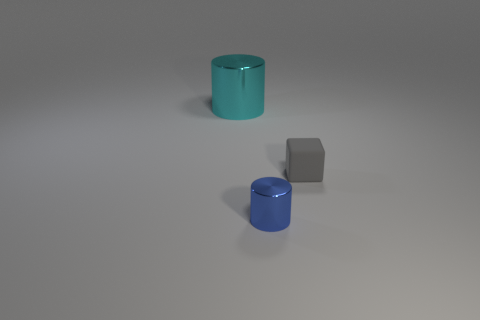Is there any other thing that is the same size as the blue thing?
Your response must be concise. Yes. What color is the object that is made of the same material as the big cyan cylinder?
Provide a succinct answer. Blue. Is there a blue metal thing of the same size as the blue cylinder?
Provide a succinct answer. No. What material is the tiny blue object that is the same shape as the large metal thing?
Ensure brevity in your answer.  Metal. What is the shape of the other thing that is the same size as the blue shiny thing?
Ensure brevity in your answer.  Cube. Is there another shiny thing of the same shape as the tiny blue object?
Offer a very short reply. Yes. What shape is the metal thing that is to the left of the metallic cylinder that is in front of the big cylinder?
Your answer should be compact. Cylinder. The blue object has what shape?
Make the answer very short. Cylinder. There is a cylinder left of the metal object that is on the right side of the thing behind the gray matte block; what is it made of?
Provide a succinct answer. Metal. What number of other things are made of the same material as the gray object?
Your response must be concise. 0. 